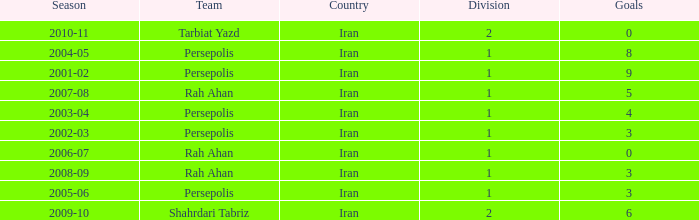What is the average Goals, when Team is "Rah Ahan", and when Division is less than 1? None. 